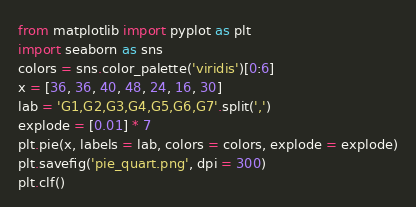<code> <loc_0><loc_0><loc_500><loc_500><_Python_>from matplotlib import pyplot as plt
import seaborn as sns
colors = sns.color_palette('viridis')[0:6]
x = [36, 36, 40, 48, 24, 16, 30]
lab = 'G1,G2,G3,G4,G5,G6,G7'.split(',')
explode = [0.01] * 7
plt.pie(x, labels = lab, colors = colors, explode = explode)
plt.savefig('pie_quart.png', dpi = 300)
plt.clf()</code> 